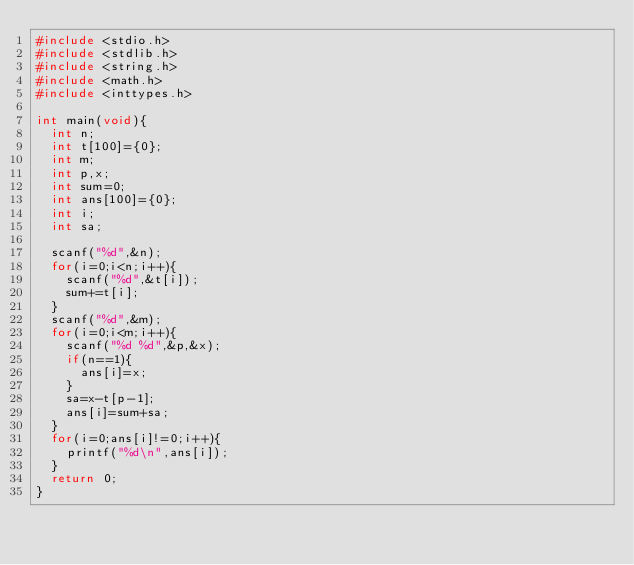Convert code to text. <code><loc_0><loc_0><loc_500><loc_500><_C_>#include <stdio.h>
#include <stdlib.h>
#include <string.h>
#include <math.h>
#include <inttypes.h>

int main(void){
	int n;
	int t[100]={0};
	int m;
	int p,x;
	int sum=0;
	int ans[100]={0};
	int i;
	int sa;

	scanf("%d",&n);
	for(i=0;i<n;i++){
		scanf("%d",&t[i]);
		sum+=t[i];
	}
	scanf("%d",&m);
	for(i=0;i<m;i++){
		scanf("%d %d",&p,&x);
		if(n==1){
			ans[i]=x;
		}
		sa=x-t[p-1];
		ans[i]=sum+sa;
	}
	for(i=0;ans[i]!=0;i++){
		printf("%d\n",ans[i]);
	}
	return 0;
}
</code> 